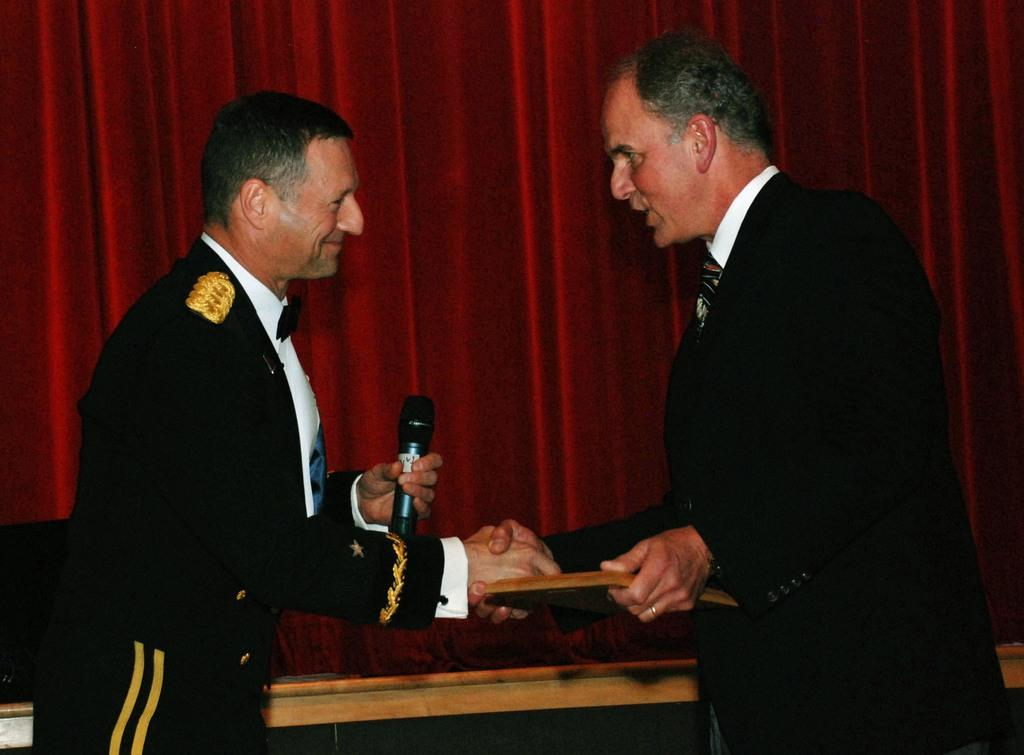How many people are in the image? There are two men in the image. What are the men doing in the image? The men are standing and shaking hands. Can you describe the man holding an object in the image? One man is holding a microphone. What can be seen in the background of the image? There is a curtain in the background of the image. What type of lamp is hanging above the men in the image? There is no lamp present in the image; it only features two men shaking hands and one holding a microphone. How many bulbs can be seen on the faucet in the image? There is no faucet or bulb present in the image. 